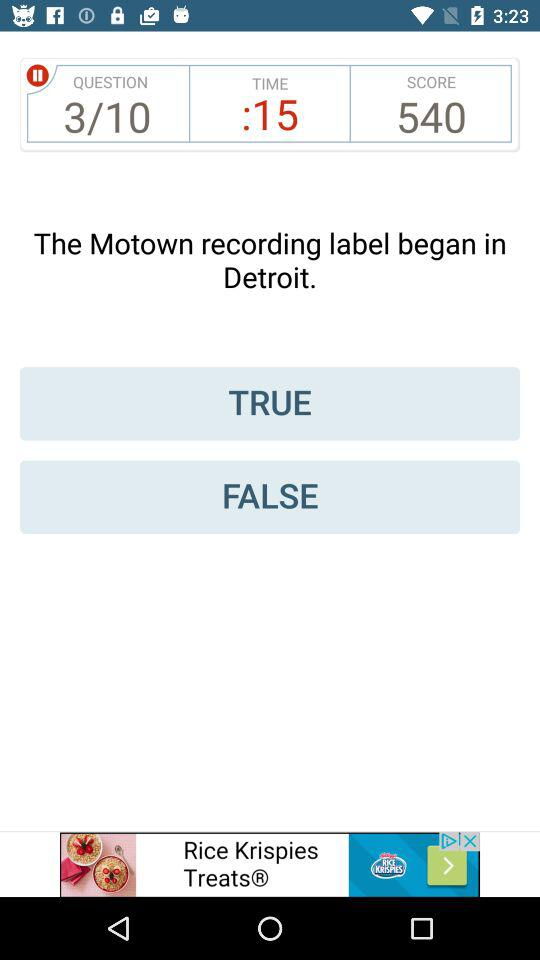How many more seconds than minutes are there in the time shown?
Answer the question using a single word or phrase. 15 